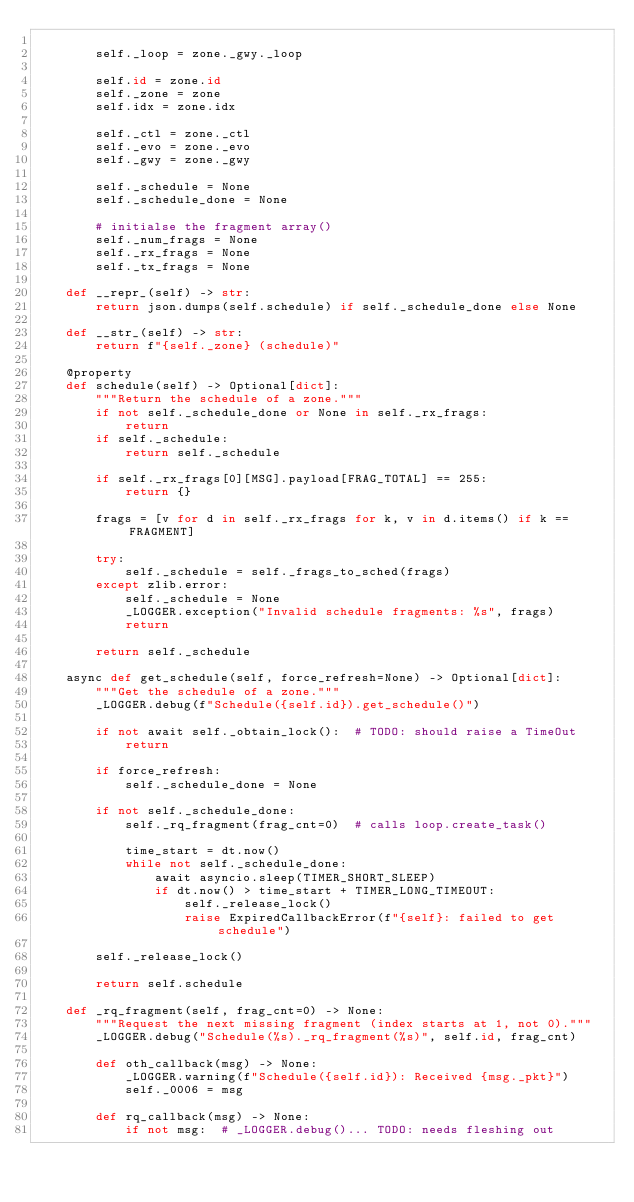Convert code to text. <code><loc_0><loc_0><loc_500><loc_500><_Python_>
        self._loop = zone._gwy._loop

        self.id = zone.id
        self._zone = zone
        self.idx = zone.idx

        self._ctl = zone._ctl
        self._evo = zone._evo
        self._gwy = zone._gwy

        self._schedule = None
        self._schedule_done = None

        # initialse the fragment array()
        self._num_frags = None
        self._rx_frags = None
        self._tx_frags = None

    def __repr_(self) -> str:
        return json.dumps(self.schedule) if self._schedule_done else None

    def __str_(self) -> str:
        return f"{self._zone} (schedule)"

    @property
    def schedule(self) -> Optional[dict]:
        """Return the schedule of a zone."""
        if not self._schedule_done or None in self._rx_frags:
            return
        if self._schedule:
            return self._schedule

        if self._rx_frags[0][MSG].payload[FRAG_TOTAL] == 255:
            return {}

        frags = [v for d in self._rx_frags for k, v in d.items() if k == FRAGMENT]

        try:
            self._schedule = self._frags_to_sched(frags)
        except zlib.error:
            self._schedule = None
            _LOGGER.exception("Invalid schedule fragments: %s", frags)
            return

        return self._schedule

    async def get_schedule(self, force_refresh=None) -> Optional[dict]:
        """Get the schedule of a zone."""
        _LOGGER.debug(f"Schedule({self.id}).get_schedule()")

        if not await self._obtain_lock():  # TODO: should raise a TimeOut
            return

        if force_refresh:
            self._schedule_done = None

        if not self._schedule_done:
            self._rq_fragment(frag_cnt=0)  # calls loop.create_task()

            time_start = dt.now()
            while not self._schedule_done:
                await asyncio.sleep(TIMER_SHORT_SLEEP)
                if dt.now() > time_start + TIMER_LONG_TIMEOUT:
                    self._release_lock()
                    raise ExpiredCallbackError(f"{self}: failed to get schedule")

        self._release_lock()

        return self.schedule

    def _rq_fragment(self, frag_cnt=0) -> None:
        """Request the next missing fragment (index starts at 1, not 0)."""
        _LOGGER.debug("Schedule(%s)._rq_fragment(%s)", self.id, frag_cnt)

        def oth_callback(msg) -> None:
            _LOGGER.warning(f"Schedule({self.id}): Received {msg._pkt}")
            self._0006 = msg

        def rq_callback(msg) -> None:
            if not msg:  # _LOGGER.debug()... TODO: needs fleshing out</code> 